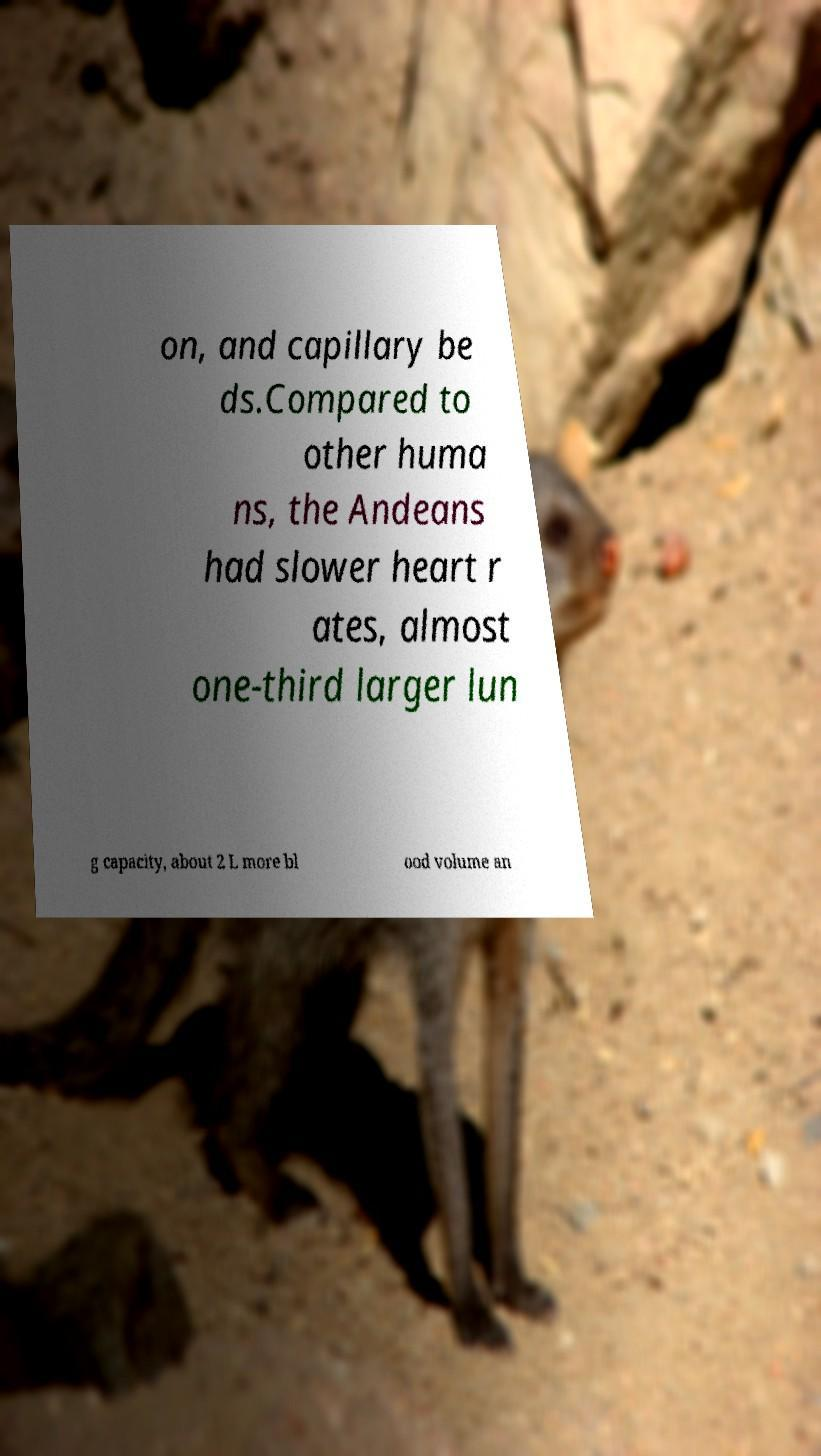Can you read and provide the text displayed in the image?This photo seems to have some interesting text. Can you extract and type it out for me? on, and capillary be ds.Compared to other huma ns, the Andeans had slower heart r ates, almost one-third larger lun g capacity, about 2 L more bl ood volume an 